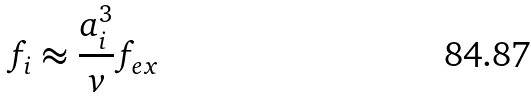Convert formula to latex. <formula><loc_0><loc_0><loc_500><loc_500>f _ { i } \approx \frac { a _ { i } ^ { 3 } } { v } f _ { e x }</formula> 